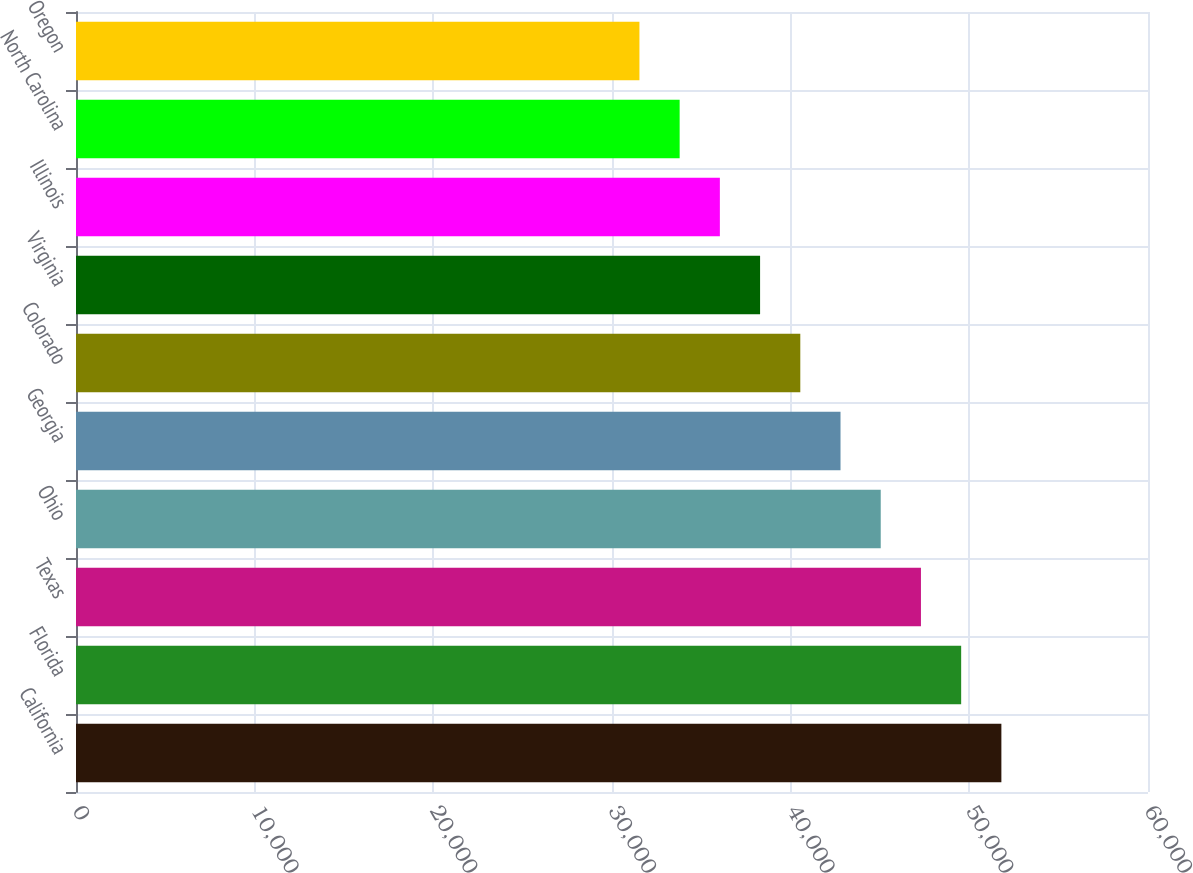Convert chart to OTSL. <chart><loc_0><loc_0><loc_500><loc_500><bar_chart><fcel>California<fcel>Florida<fcel>Texas<fcel>Ohio<fcel>Georgia<fcel>Colorado<fcel>Virginia<fcel>Illinois<fcel>North Carolina<fcel>Oregon<nl><fcel>51793.7<fcel>49542.8<fcel>47291.9<fcel>45041<fcel>42790.1<fcel>40539.2<fcel>38288.3<fcel>36037.4<fcel>33786.5<fcel>31535.6<nl></chart> 